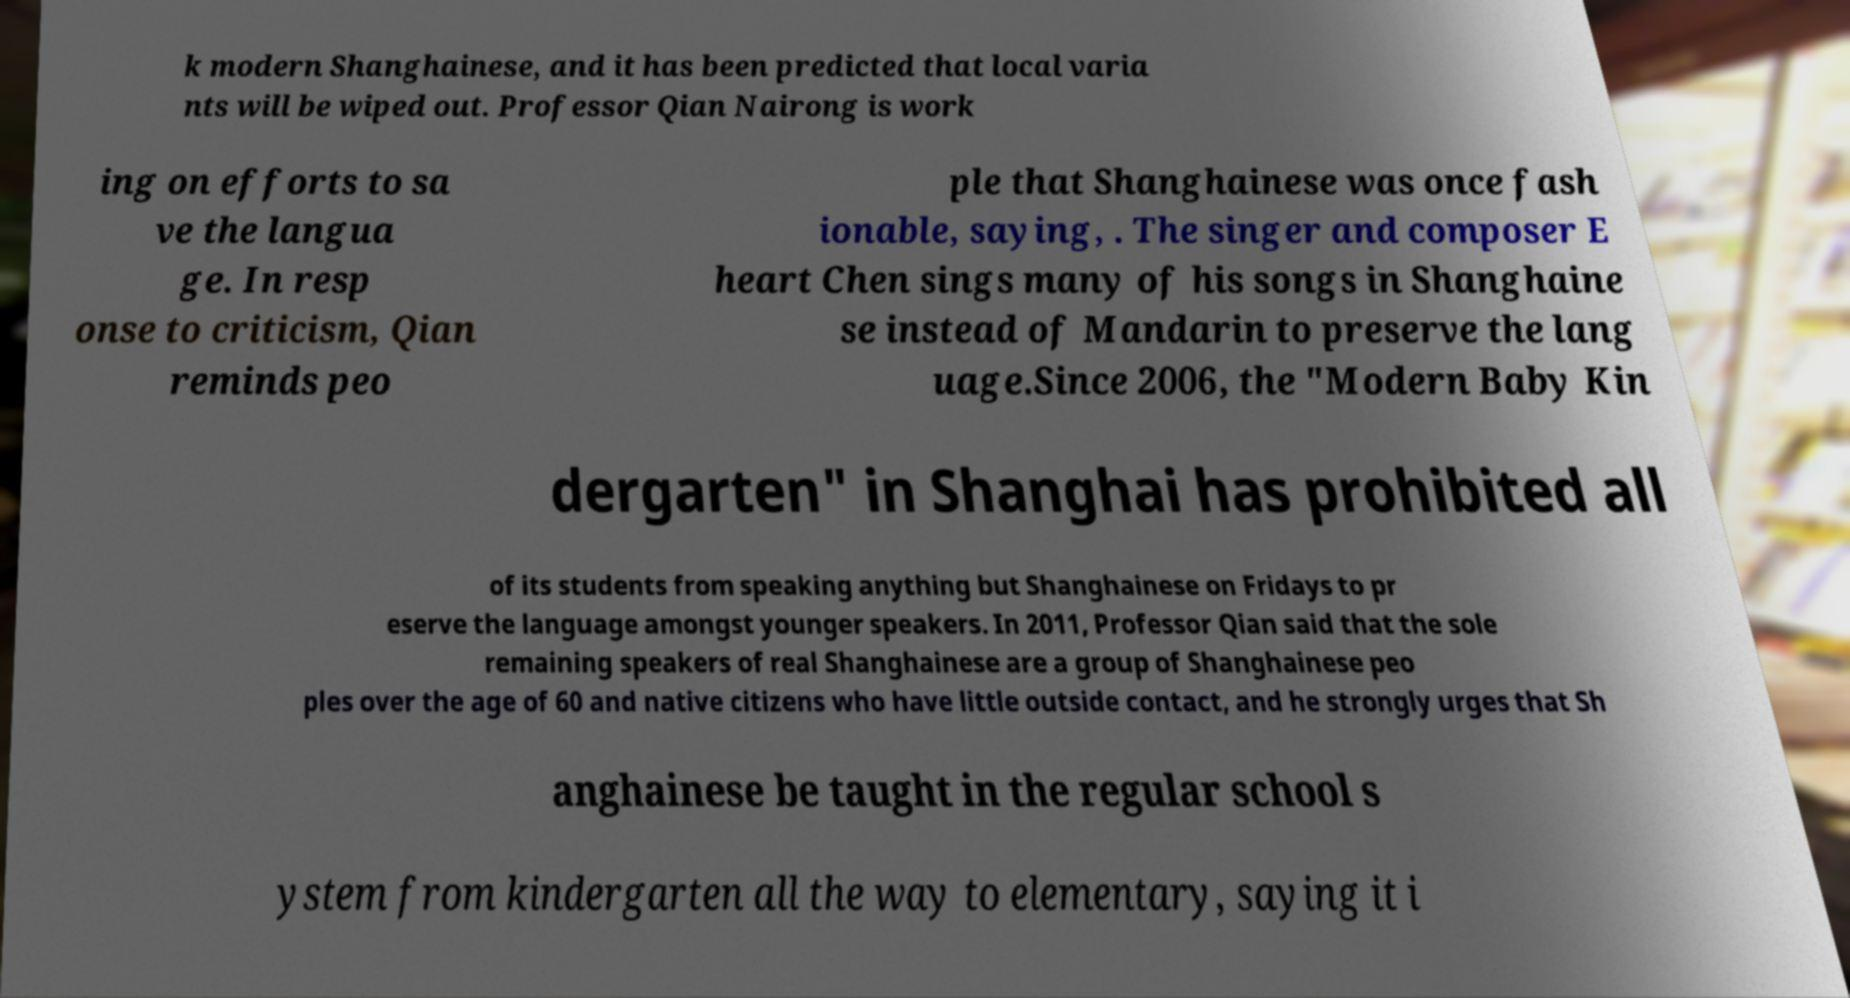There's text embedded in this image that I need extracted. Can you transcribe it verbatim? k modern Shanghainese, and it has been predicted that local varia nts will be wiped out. Professor Qian Nairong is work ing on efforts to sa ve the langua ge. In resp onse to criticism, Qian reminds peo ple that Shanghainese was once fash ionable, saying, . The singer and composer E heart Chen sings many of his songs in Shanghaine se instead of Mandarin to preserve the lang uage.Since 2006, the "Modern Baby Kin dergarten" in Shanghai has prohibited all of its students from speaking anything but Shanghainese on Fridays to pr eserve the language amongst younger speakers. In 2011, Professor Qian said that the sole remaining speakers of real Shanghainese are a group of Shanghainese peo ples over the age of 60 and native citizens who have little outside contact, and he strongly urges that Sh anghainese be taught in the regular school s ystem from kindergarten all the way to elementary, saying it i 